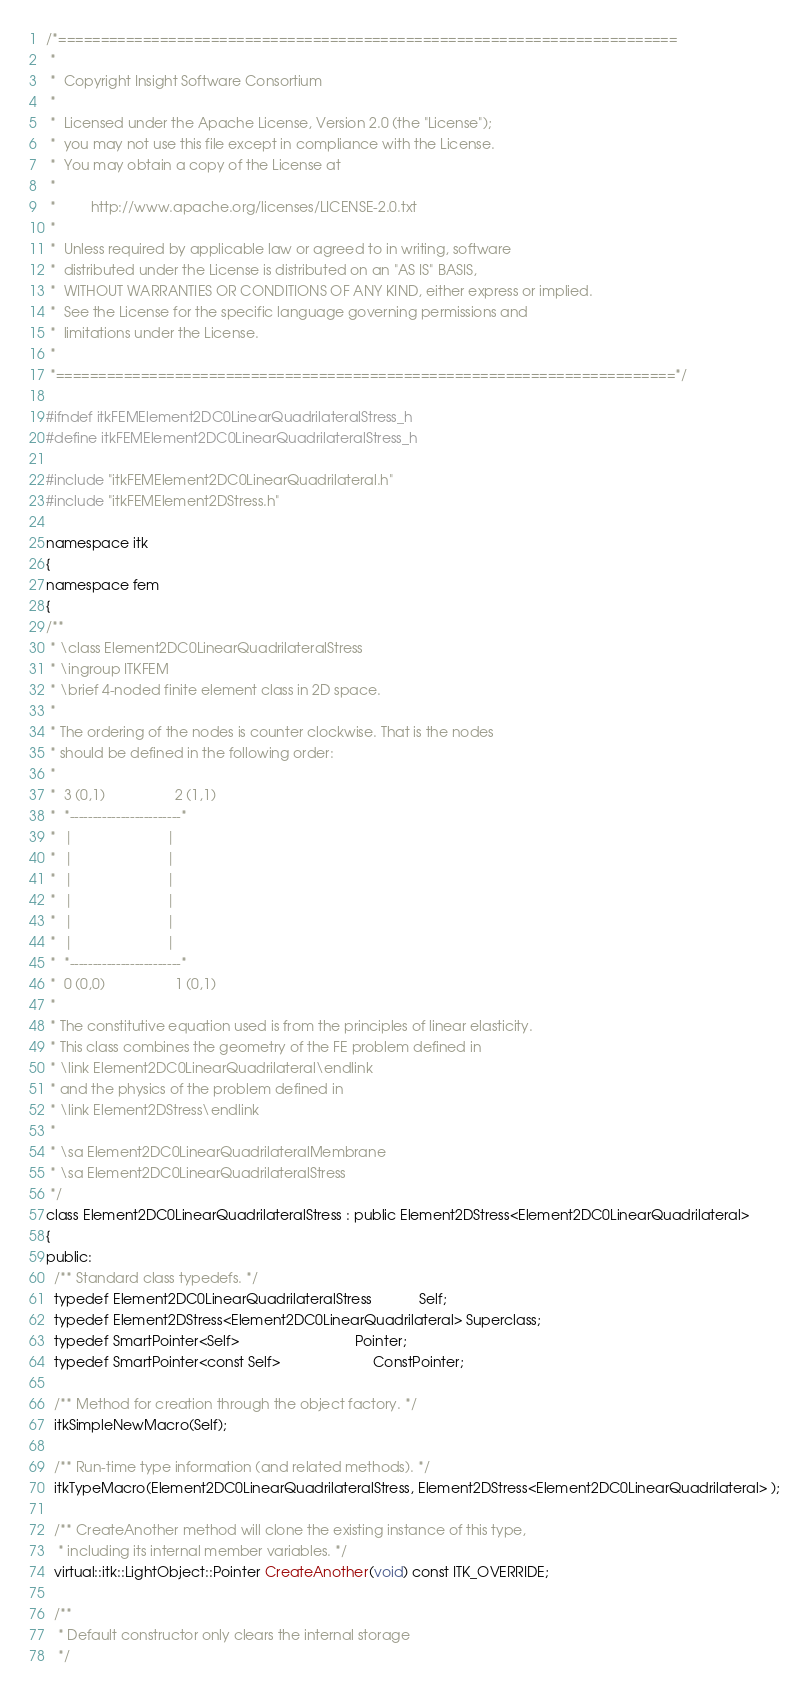Convert code to text. <code><loc_0><loc_0><loc_500><loc_500><_C_>/*=========================================================================
 *
 *  Copyright Insight Software Consortium
 *
 *  Licensed under the Apache License, Version 2.0 (the "License");
 *  you may not use this file except in compliance with the License.
 *  You may obtain a copy of the License at
 *
 *         http://www.apache.org/licenses/LICENSE-2.0.txt
 *
 *  Unless required by applicable law or agreed to in writing, software
 *  distributed under the License is distributed on an "AS IS" BASIS,
 *  WITHOUT WARRANTIES OR CONDITIONS OF ANY KIND, either express or implied.
 *  See the License for the specific language governing permissions and
 *  limitations under the License.
 *
 *=========================================================================*/

#ifndef itkFEMElement2DC0LinearQuadrilateralStress_h
#define itkFEMElement2DC0LinearQuadrilateralStress_h

#include "itkFEMElement2DC0LinearQuadrilateral.h"
#include "itkFEMElement2DStress.h"

namespace itk
{
namespace fem
{
/**
 * \class Element2DC0LinearQuadrilateralStress
 * \ingroup ITKFEM
 * \brief 4-noded finite element class in 2D space.
 *
 * The ordering of the nodes is counter clockwise. That is the nodes
 * should be defined in the following order:
 *
 *  3 (0,1)                  2 (1,1)
 *  *------------------------*
 *  |                        |
 *  |                        |
 *  |                        |
 *  |                        |
 *  |                        |
 *  |                        |
 *  *------------------------*
 *  0 (0,0)                  1 (0,1)
 *
 * The constitutive equation used is from the principles of linear elasticity.
 * This class combines the geometry of the FE problem defined in
 * \link Element2DC0LinearQuadrilateral\endlink
 * and the physics of the problem defined in
 * \link Element2DStress\endlink
 *
 * \sa Element2DC0LinearQuadrilateralMembrane
 * \sa Element2DC0LinearQuadrilateralStress
 */
class Element2DC0LinearQuadrilateralStress : public Element2DStress<Element2DC0LinearQuadrilateral>
{
public:
  /** Standard class typedefs. */
  typedef Element2DC0LinearQuadrilateralStress            Self;
  typedef Element2DStress<Element2DC0LinearQuadrilateral> Superclass;
  typedef SmartPointer<Self>                              Pointer;
  typedef SmartPointer<const Self>                        ConstPointer;

  /** Method for creation through the object factory. */
  itkSimpleNewMacro(Self);

  /** Run-time type information (and related methods). */
  itkTypeMacro(Element2DC0LinearQuadrilateralStress, Element2DStress<Element2DC0LinearQuadrilateral> );

  /** CreateAnother method will clone the existing instance of this type,
   * including its internal member variables. */
  virtual::itk::LightObject::Pointer CreateAnother(void) const ITK_OVERRIDE;

  /**
   * Default constructor only clears the internal storage
   */</code> 